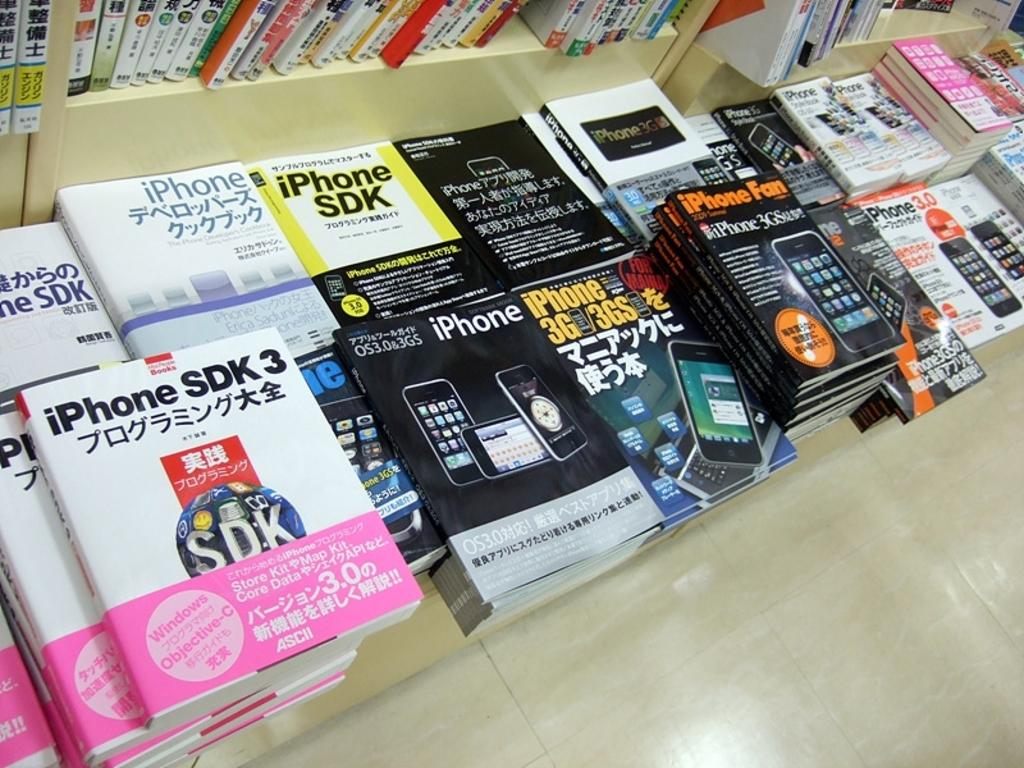<image>
Give a short and clear explanation of the subsequent image. The white and pink book is titles Iphone SDK 